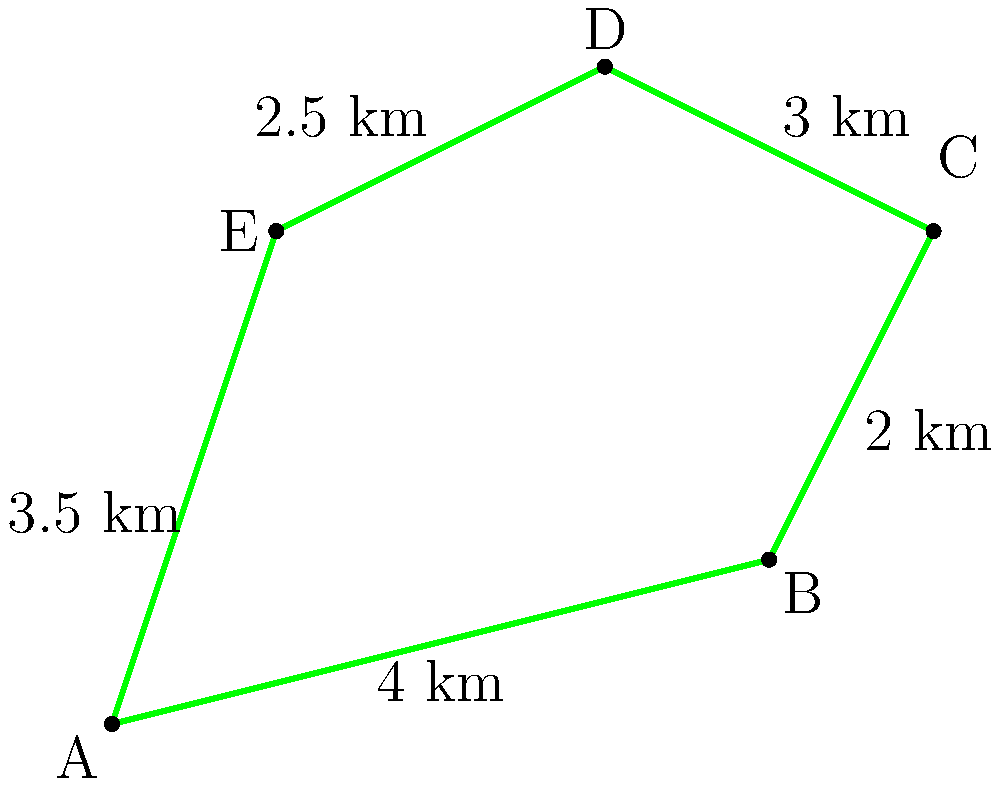A newly designated protected wetland area in coastal North Carolina has an irregular shape as shown in the diagram. The sides of this area measure 4 km, 2 km, 3 km, 2.5 km, and 3.5 km. What is the total perimeter of this protected wetland area? Express your answer in kilometers. To find the perimeter of the irregular wetland area, we need to add up the lengths of all sides. Let's go through this step-by-step:

1. Identify the lengths of each side:
   Side AB = 4 km
   Side BC = 2 km
   Side CD = 3 km
   Side DE = 2.5 km
   Side EA = 3.5 km

2. Add up all the side lengths:
   Perimeter = AB + BC + CD + DE + EA
   Perimeter = 4 + 2 + 3 + 2.5 + 3.5

3. Perform the addition:
   Perimeter = 15 km

Therefore, the total perimeter of the protected wetland area is 15 kilometers.

This calculation is important for environmental management and conservation efforts. Knowing the perimeter can help in planning fencing, defining buffer zones, or estimating the resources needed for maintenance and protection of the wetland area.
Answer: 15 km 